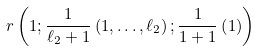<formula> <loc_0><loc_0><loc_500><loc_500>r \left ( 1 ; \frac { 1 } { \ell _ { 2 } + 1 } \left ( 1 , \dots , \ell _ { 2 } \right ) ; \frac { 1 } { 1 + 1 } \left ( 1 \right ) \right )</formula> 